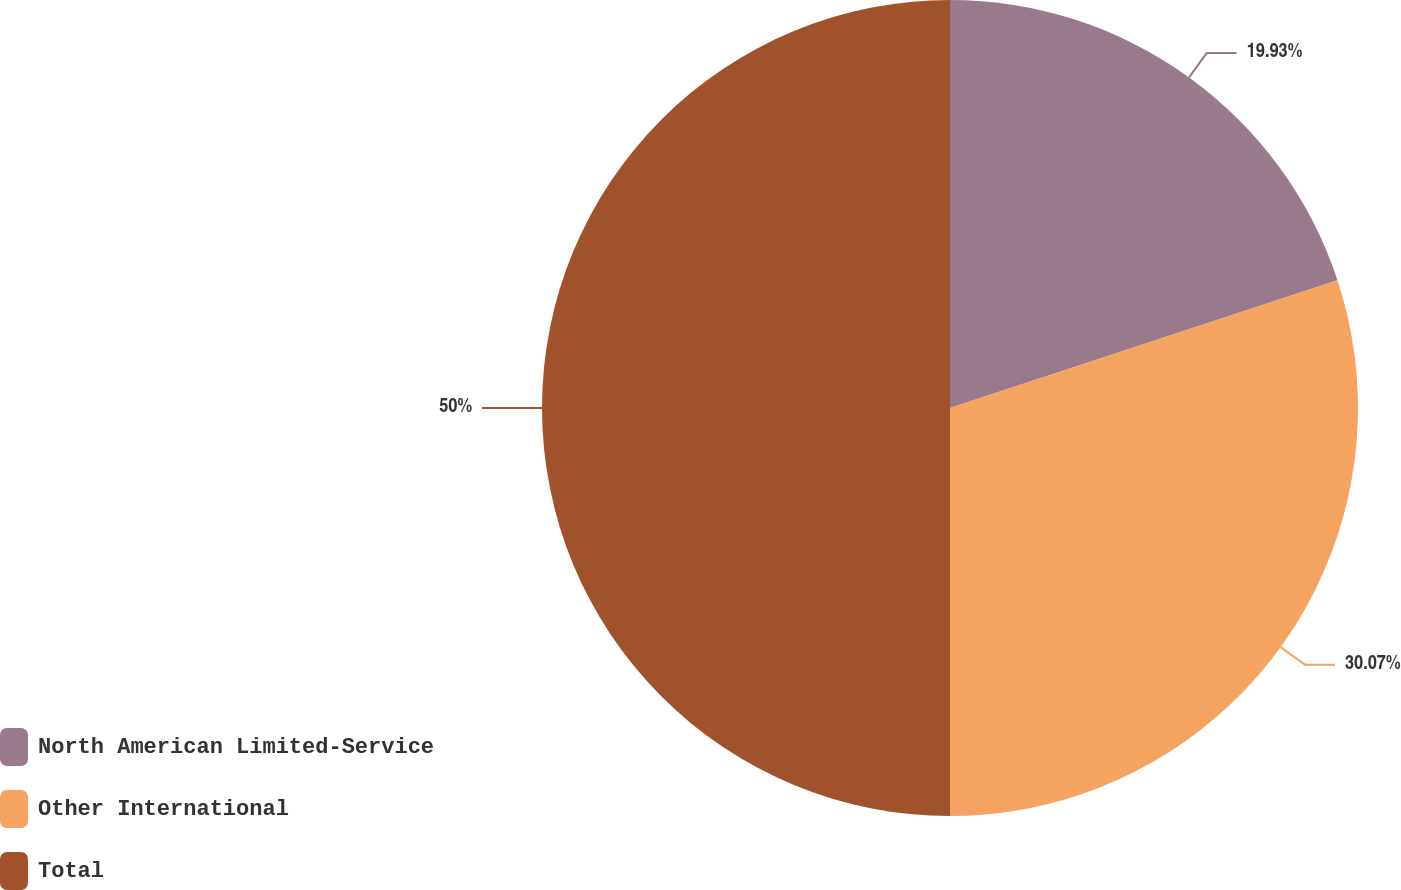Convert chart. <chart><loc_0><loc_0><loc_500><loc_500><pie_chart><fcel>North American Limited-Service<fcel>Other International<fcel>Total<nl><fcel>19.93%<fcel>30.07%<fcel>50.0%<nl></chart> 